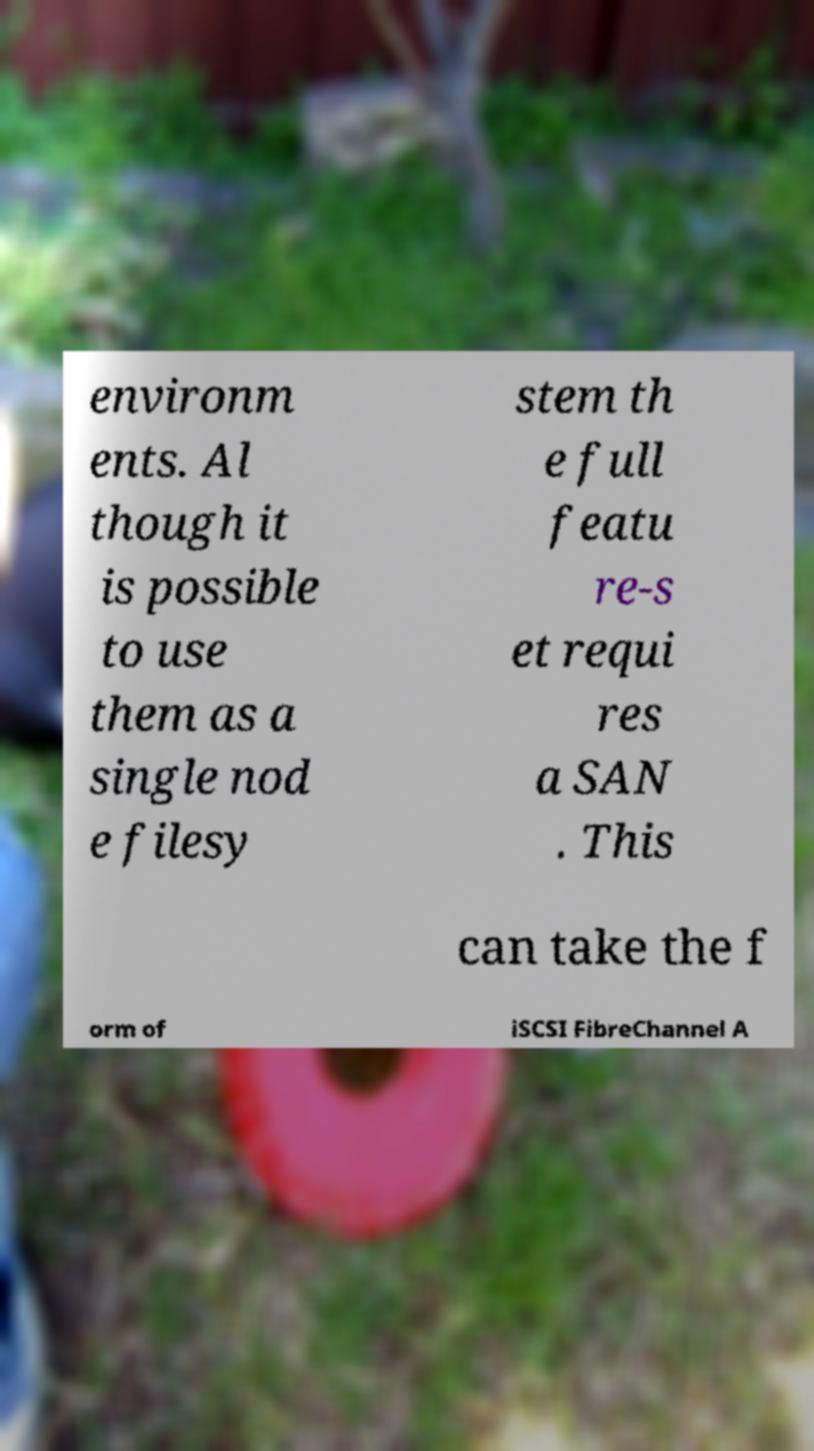Could you assist in decoding the text presented in this image and type it out clearly? environm ents. Al though it is possible to use them as a single nod e filesy stem th e full featu re-s et requi res a SAN . This can take the f orm of iSCSI FibreChannel A 